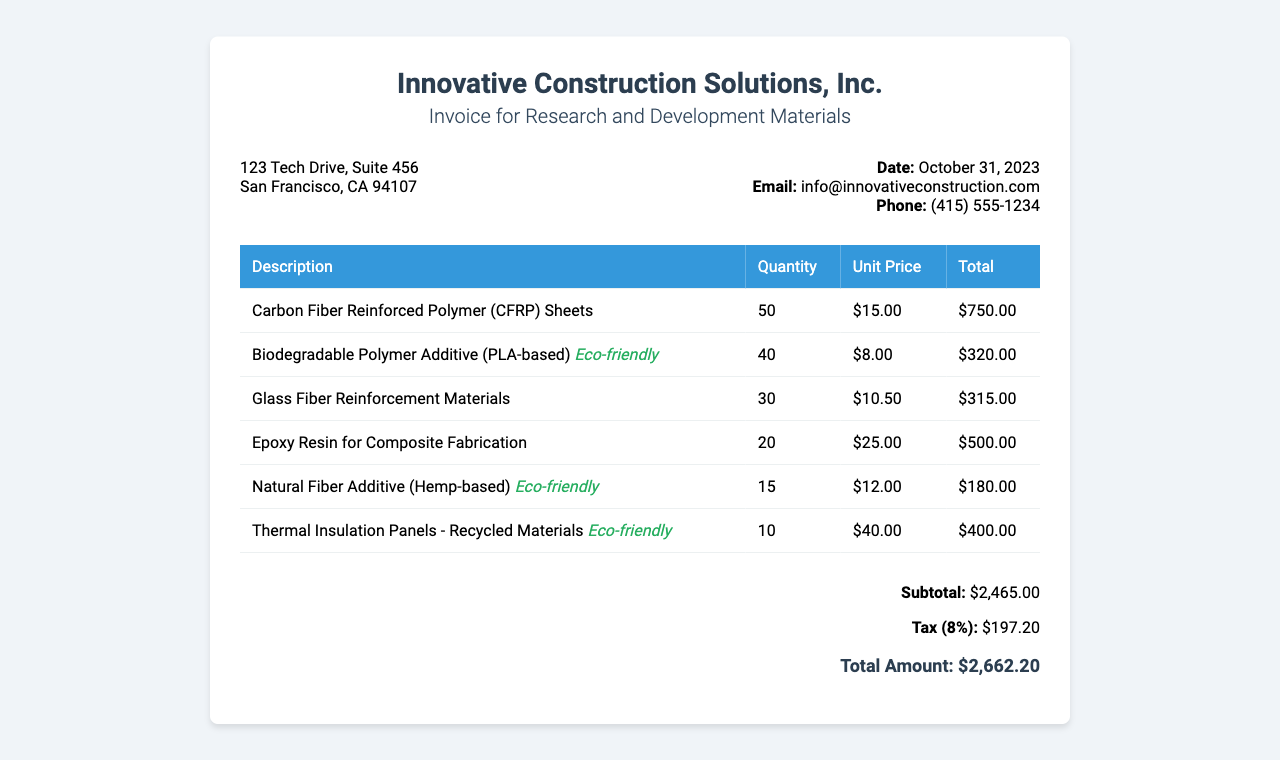What is the date of the invoice? The date of the invoice is provided in the document, specifically under the contact details section.
Answer: October 31, 2023 What is the total amount due? The total amount is calculated at the end of the invoice, summarizing the total cost including tax.
Answer: $2,662.20 How many Carbon Fiber Reinforced Polymer (CFRP) Sheets were purchased? The quantity purchased is listed in the itemized section of the invoice for the CFRP Sheets.
Answer: 50 Which eco-friendly additive is biodegradable? The eco-friendly additives are specified in the itemized section with a note regarding their nature.
Answer: Biodegradable Polymer Additive (PLA-based) What is the subtotal amount before tax? The subtotal is calculated from all itemized costs before applying the tax rate, and it’s presented in the total section.
Answer: $2,465.00 What is the unit price of the Natural Fiber Additive? The unit price for items is listed in the itemized table for the Natural Fiber Additive.
Answer: $12.00 How many Thermal Insulation Panels were ordered? The quantity ordered is mentioned in the invoice under the section that lists the items purchased.
Answer: 10 What is the percentage of tax applied? The tax percentage is indicated in the total section of the invoice, showing how much tax was added to the subtotal.
Answer: 8% What company issued the invoice? The company name is prominently displayed at the top of the invoice document.
Answer: Innovative Construction Solutions, Inc 